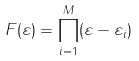Convert formula to latex. <formula><loc_0><loc_0><loc_500><loc_500>F ( \varepsilon ) = \prod _ { i = 1 } ^ { M } ( \varepsilon - \varepsilon _ { i } )</formula> 